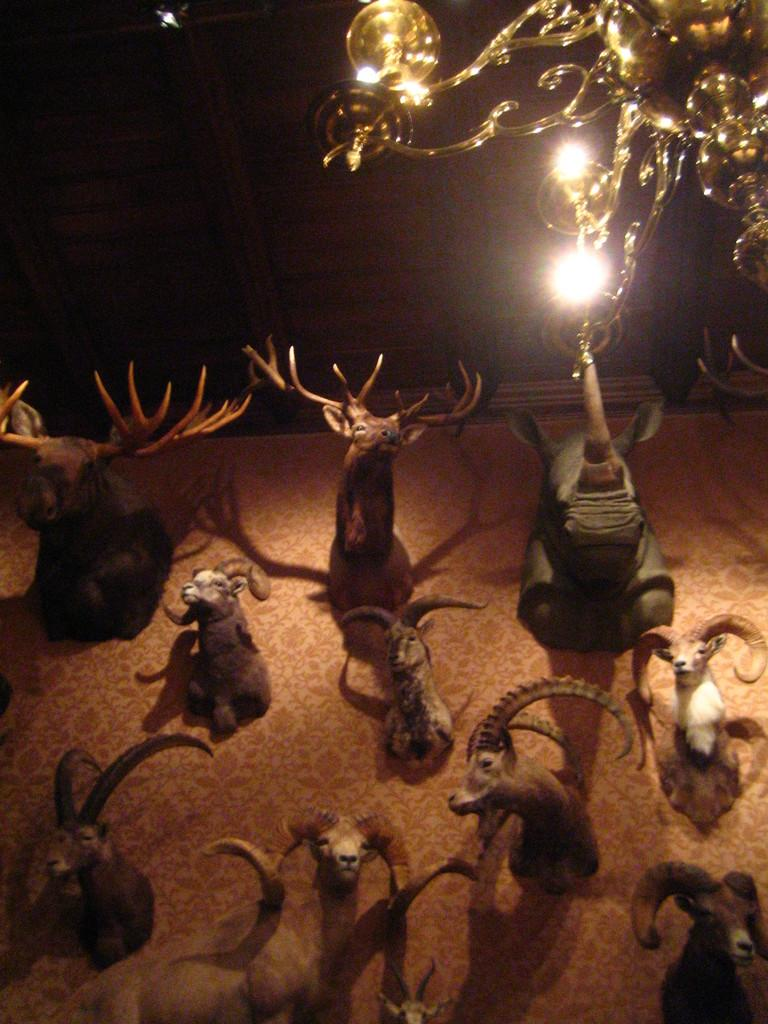What type of objects are depicted in the image? There are sculptures of animals in the image. Can you describe the golden-colored object with lights attached to it? It is located in the top right corner of the image. How many snails are present in the image? There are no snails depicted in the image; it features sculptures of animals. What type of stick is being used by the group in the image? There is no group or stick present in the image. 